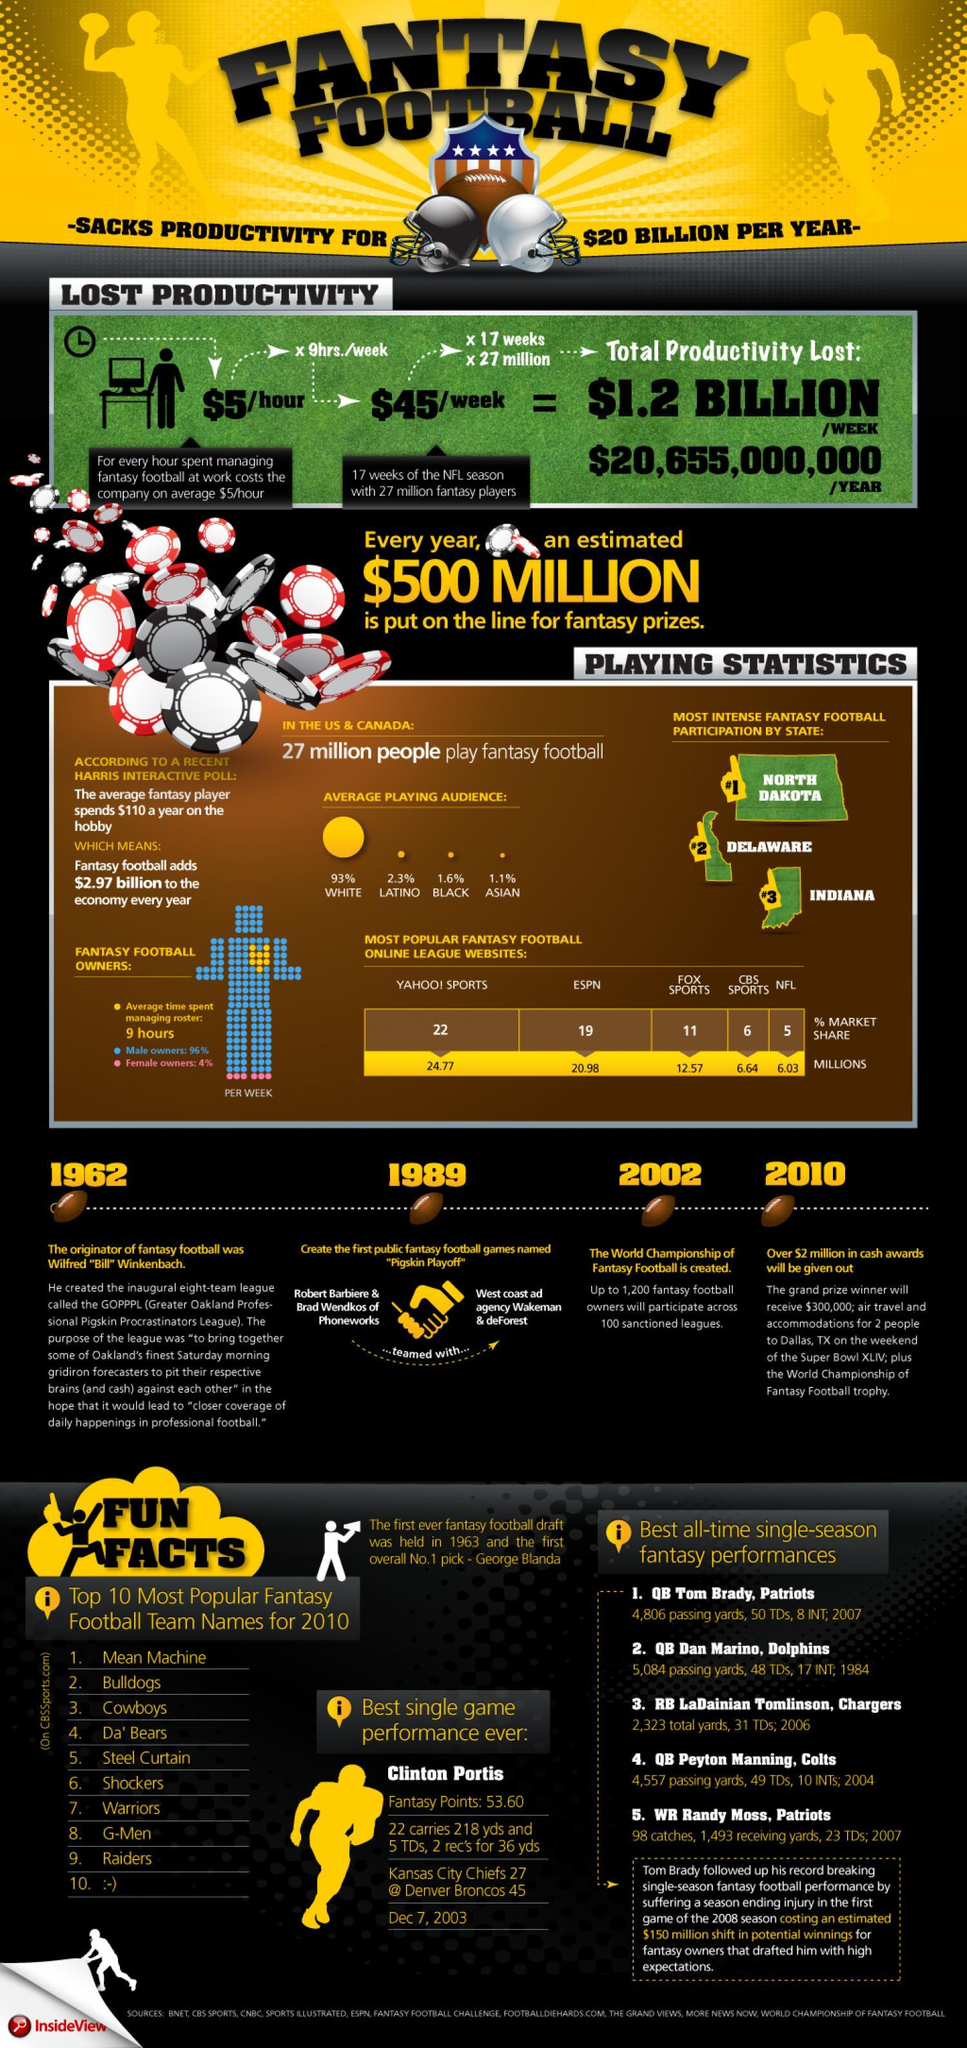Which of all three states have the most intense fantasy football participation?
Answer the question with a short phrase. North Dakota, Delaware, Indiana In which year Pigskin Playoff created? 1989 In which year the world championship of fantasy football created? 2002 